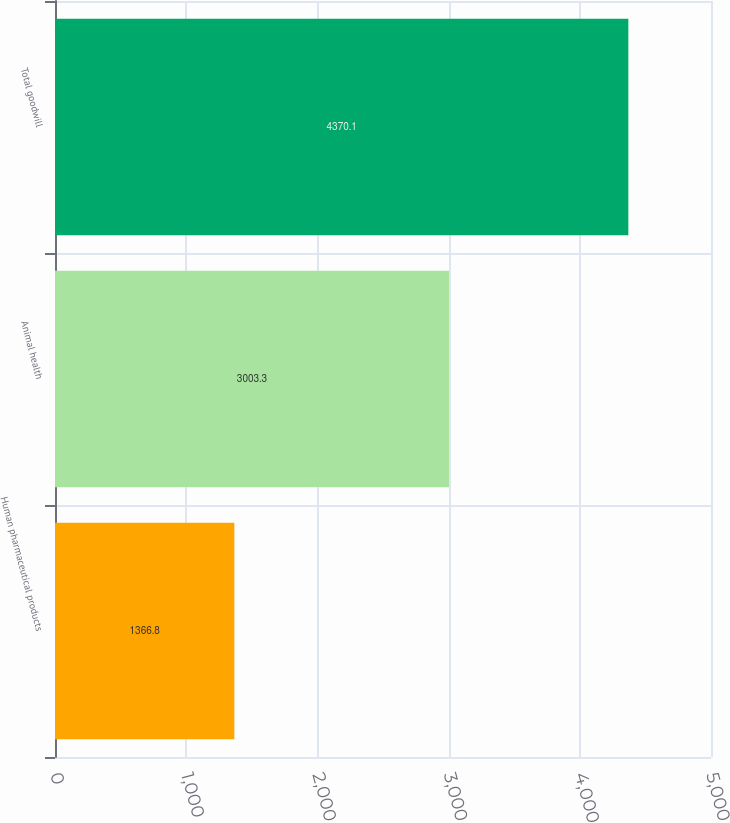Convert chart. <chart><loc_0><loc_0><loc_500><loc_500><bar_chart><fcel>Human pharmaceutical products<fcel>Animal health<fcel>Total goodwill<nl><fcel>1366.8<fcel>3003.3<fcel>4370.1<nl></chart> 